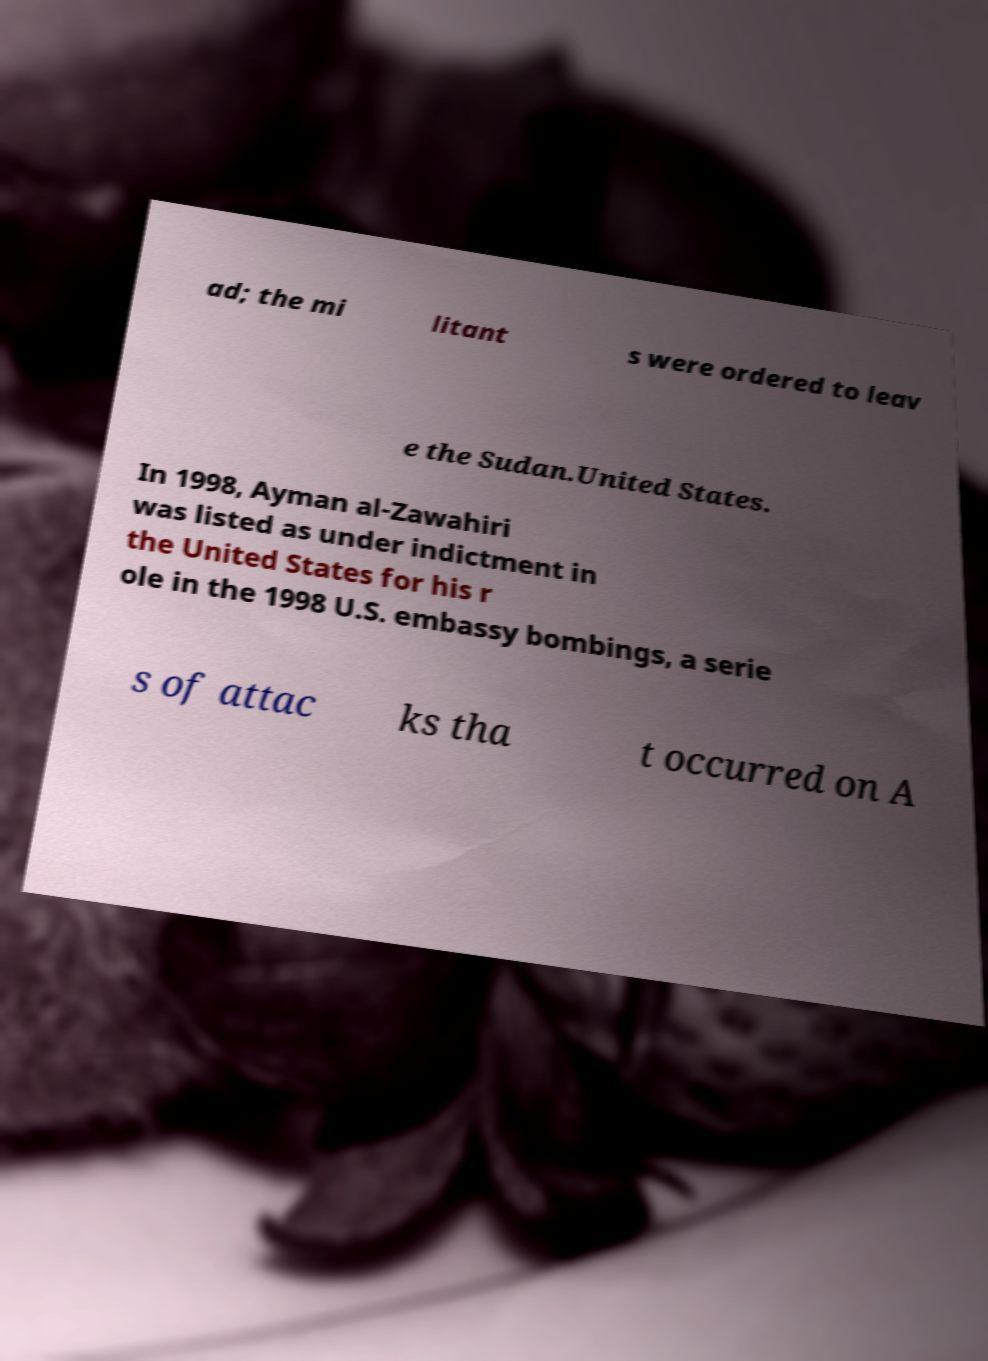There's text embedded in this image that I need extracted. Can you transcribe it verbatim? ad; the mi litant s were ordered to leav e the Sudan.United States. In 1998, Ayman al-Zawahiri was listed as under indictment in the United States for his r ole in the 1998 U.S. embassy bombings, a serie s of attac ks tha t occurred on A 